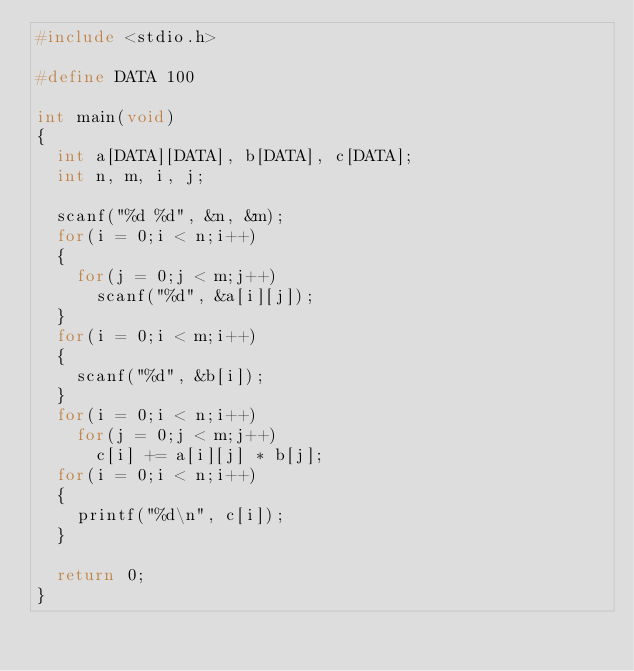<code> <loc_0><loc_0><loc_500><loc_500><_C_>#include <stdio.h>

#define DATA 100

int main(void)
{
	int a[DATA][DATA], b[DATA], c[DATA];
	int n, m, i, j;

	scanf("%d %d", &n, &m);
	for(i = 0;i < n;i++)
	{
		for(j = 0;j < m;j++)
			scanf("%d", &a[i][j]);
	}
	for(i = 0;i < m;i++)
	{
		scanf("%d", &b[i]);
	}
	for(i = 0;i < n;i++)
		for(j = 0;j < m;j++)
			c[i] += a[i][j] * b[j];
	for(i = 0;i < n;i++)
	{
		printf("%d\n", c[i]);
	}

	return 0;
}</code> 